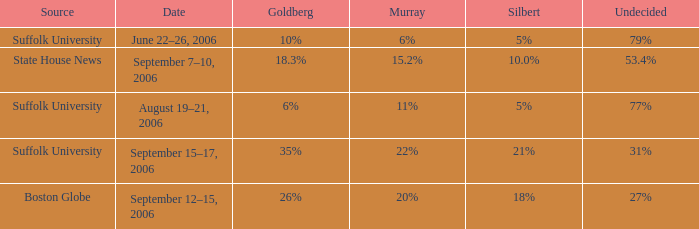What is the date of the poll where Murray had 11% from the Suffolk University source? August 19–21, 2006. 